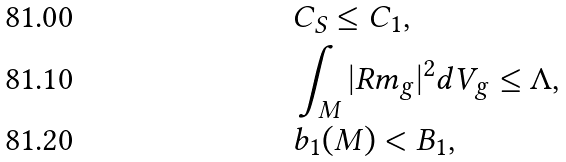Convert formula to latex. <formula><loc_0><loc_0><loc_500><loc_500>& C _ { S } \leq C _ { 1 } , \\ & \int _ { M } | R m _ { g } | ^ { 2 } d V _ { g } \leq \Lambda , \\ & b _ { 1 } ( M ) < B _ { 1 } ,</formula> 